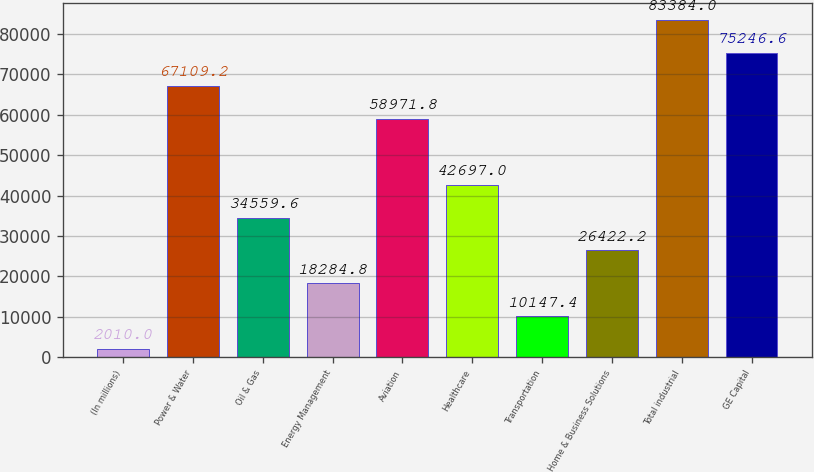Convert chart to OTSL. <chart><loc_0><loc_0><loc_500><loc_500><bar_chart><fcel>(In millions)<fcel>Power & Water<fcel>Oil & Gas<fcel>Energy Management<fcel>Aviation<fcel>Healthcare<fcel>Transportation<fcel>Home & Business Solutions<fcel>Total industrial<fcel>GE Capital<nl><fcel>2010<fcel>67109.2<fcel>34559.6<fcel>18284.8<fcel>58971.8<fcel>42697<fcel>10147.4<fcel>26422.2<fcel>83384<fcel>75246.6<nl></chart> 